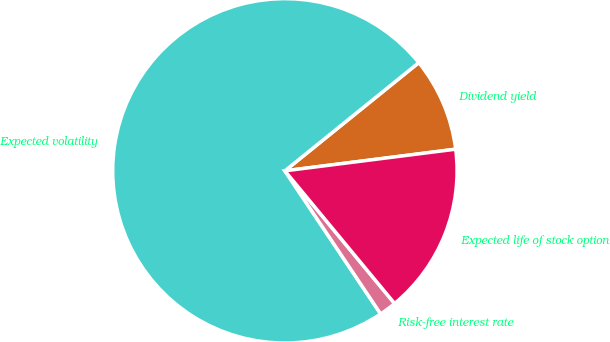Convert chart to OTSL. <chart><loc_0><loc_0><loc_500><loc_500><pie_chart><fcel>Dividend yield<fcel>Expected volatility<fcel>Risk-free interest rate<fcel>Expected life of stock option<nl><fcel>8.81%<fcel>73.57%<fcel>1.61%<fcel>16.01%<nl></chart> 